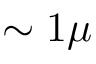<formula> <loc_0><loc_0><loc_500><loc_500>\sim 1 \mu</formula> 